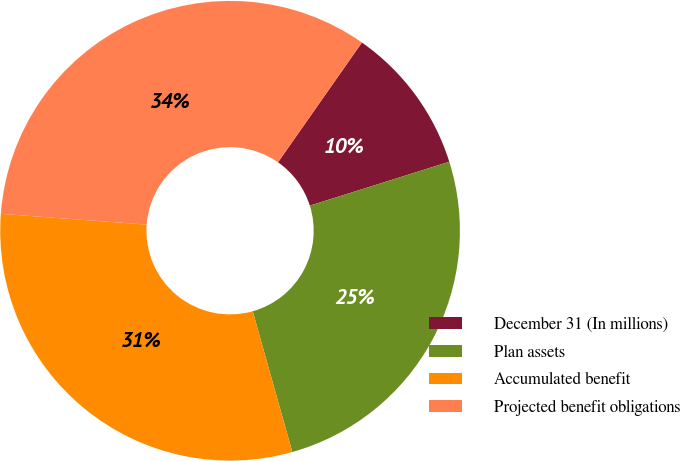Convert chart to OTSL. <chart><loc_0><loc_0><loc_500><loc_500><pie_chart><fcel>December 31 (In millions)<fcel>Plan assets<fcel>Accumulated benefit<fcel>Projected benefit obligations<nl><fcel>10.42%<fcel>25.49%<fcel>30.54%<fcel>33.55%<nl></chart> 